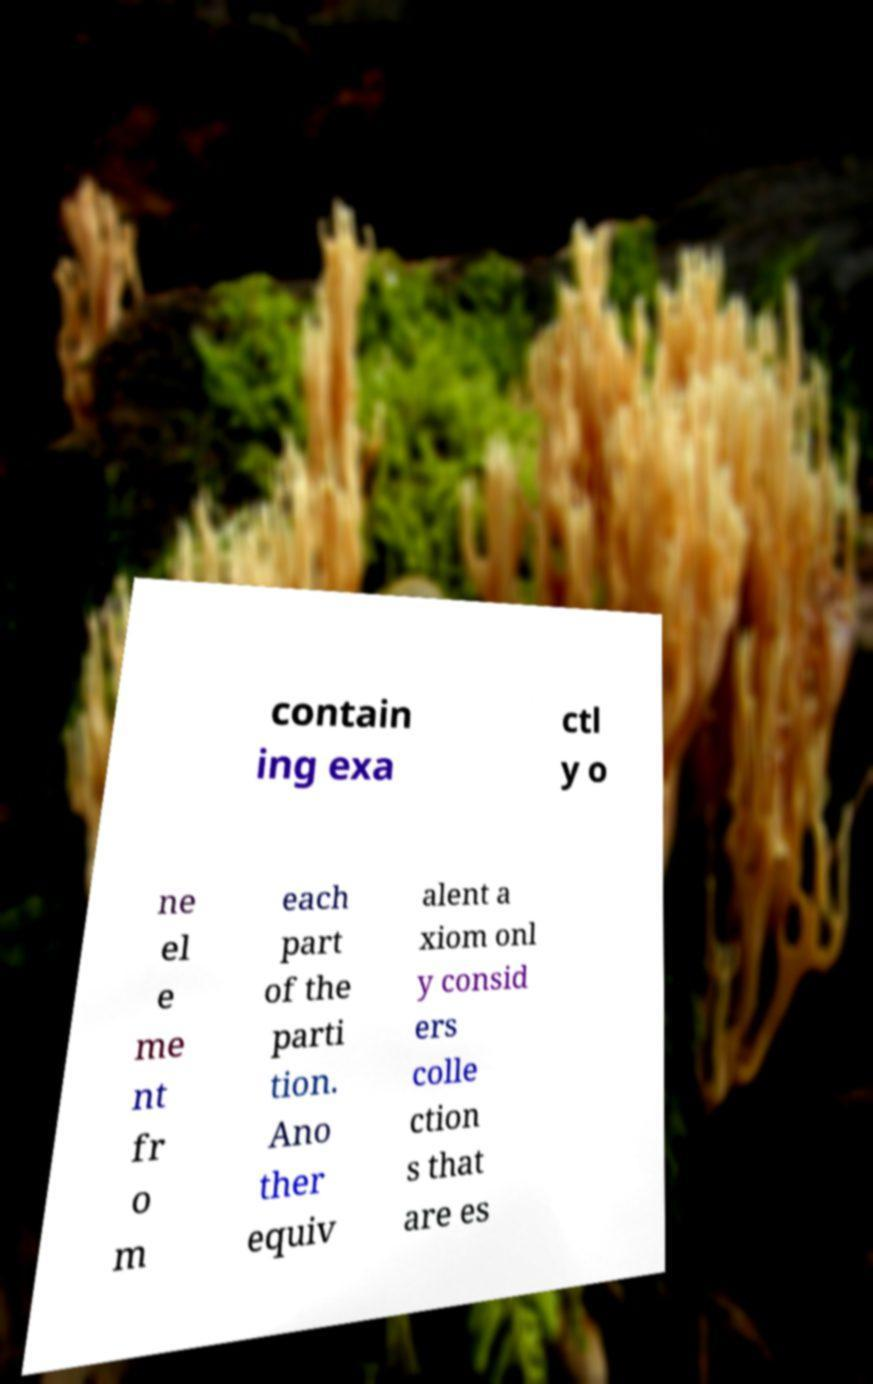Could you extract and type out the text from this image? contain ing exa ctl y o ne el e me nt fr o m each part of the parti tion. Ano ther equiv alent a xiom onl y consid ers colle ction s that are es 